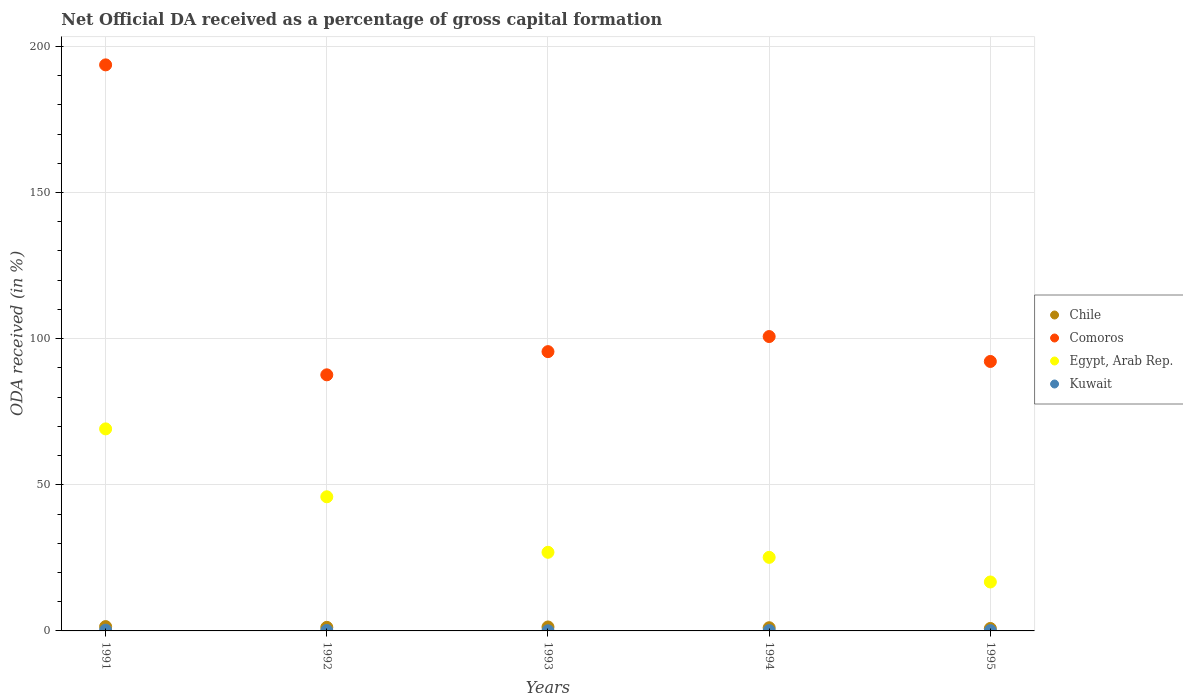Is the number of dotlines equal to the number of legend labels?
Provide a succinct answer. Yes. What is the net ODA received in Chile in 1993?
Your answer should be very brief. 1.35. Across all years, what is the maximum net ODA received in Chile?
Provide a succinct answer. 1.48. Across all years, what is the minimum net ODA received in Chile?
Provide a succinct answer. 0.84. In which year was the net ODA received in Comoros minimum?
Ensure brevity in your answer.  1992. What is the total net ODA received in Kuwait in the graph?
Offer a terse response. 0.67. What is the difference between the net ODA received in Kuwait in 1991 and that in 1995?
Offer a terse response. 0.15. What is the difference between the net ODA received in Egypt, Arab Rep. in 1991 and the net ODA received in Kuwait in 1995?
Provide a succinct answer. 69.03. What is the average net ODA received in Egypt, Arab Rep. per year?
Your answer should be very brief. 36.77. In the year 1992, what is the difference between the net ODA received in Chile and net ODA received in Comoros?
Make the answer very short. -86.4. In how many years, is the net ODA received in Kuwait greater than 110 %?
Offer a terse response. 0. What is the ratio of the net ODA received in Chile in 1993 to that in 1995?
Offer a terse response. 1.61. What is the difference between the highest and the second highest net ODA received in Kuwait?
Make the answer very short. 0.11. What is the difference between the highest and the lowest net ODA received in Chile?
Offer a terse response. 0.64. Is the sum of the net ODA received in Kuwait in 1992 and 1995 greater than the maximum net ODA received in Egypt, Arab Rep. across all years?
Ensure brevity in your answer.  No. Is it the case that in every year, the sum of the net ODA received in Comoros and net ODA received in Egypt, Arab Rep.  is greater than the sum of net ODA received in Kuwait and net ODA received in Chile?
Provide a short and direct response. No. Is it the case that in every year, the sum of the net ODA received in Chile and net ODA received in Kuwait  is greater than the net ODA received in Egypt, Arab Rep.?
Your response must be concise. No. Is the net ODA received in Kuwait strictly greater than the net ODA received in Chile over the years?
Offer a terse response. No. Is the net ODA received in Comoros strictly less than the net ODA received in Egypt, Arab Rep. over the years?
Your response must be concise. No. How many years are there in the graph?
Ensure brevity in your answer.  5. What is the difference between two consecutive major ticks on the Y-axis?
Give a very brief answer. 50. Are the values on the major ticks of Y-axis written in scientific E-notation?
Your answer should be compact. No. Does the graph contain grids?
Your response must be concise. Yes. Where does the legend appear in the graph?
Your response must be concise. Center right. How many legend labels are there?
Offer a terse response. 4. How are the legend labels stacked?
Provide a short and direct response. Vertical. What is the title of the graph?
Give a very brief answer. Net Official DA received as a percentage of gross capital formation. Does "New Caledonia" appear as one of the legend labels in the graph?
Give a very brief answer. No. What is the label or title of the X-axis?
Give a very brief answer. Years. What is the label or title of the Y-axis?
Offer a terse response. ODA received (in %). What is the ODA received (in %) of Chile in 1991?
Provide a short and direct response. 1.48. What is the ODA received (in %) of Comoros in 1991?
Provide a succinct answer. 193.68. What is the ODA received (in %) of Egypt, Arab Rep. in 1991?
Your response must be concise. 69.13. What is the ODA received (in %) of Kuwait in 1991?
Your response must be concise. 0.26. What is the ODA received (in %) in Chile in 1992?
Your response must be concise. 1.22. What is the ODA received (in %) in Comoros in 1992?
Give a very brief answer. 87.63. What is the ODA received (in %) in Egypt, Arab Rep. in 1992?
Offer a very short reply. 45.89. What is the ODA received (in %) of Kuwait in 1992?
Provide a succinct answer. 0.15. What is the ODA received (in %) of Chile in 1993?
Your response must be concise. 1.35. What is the ODA received (in %) in Comoros in 1993?
Offer a very short reply. 95.56. What is the ODA received (in %) of Egypt, Arab Rep. in 1993?
Give a very brief answer. 26.9. What is the ODA received (in %) in Kuwait in 1993?
Give a very brief answer. 0.05. What is the ODA received (in %) in Chile in 1994?
Your answer should be compact. 1.09. What is the ODA received (in %) in Comoros in 1994?
Provide a succinct answer. 100.72. What is the ODA received (in %) of Egypt, Arab Rep. in 1994?
Keep it short and to the point. 25.17. What is the ODA received (in %) of Kuwait in 1994?
Provide a short and direct response. 0.11. What is the ODA received (in %) of Chile in 1995?
Ensure brevity in your answer.  0.84. What is the ODA received (in %) of Comoros in 1995?
Provide a short and direct response. 92.2. What is the ODA received (in %) of Egypt, Arab Rep. in 1995?
Give a very brief answer. 16.75. What is the ODA received (in %) in Kuwait in 1995?
Your answer should be compact. 0.11. Across all years, what is the maximum ODA received (in %) of Chile?
Your answer should be very brief. 1.48. Across all years, what is the maximum ODA received (in %) in Comoros?
Make the answer very short. 193.68. Across all years, what is the maximum ODA received (in %) in Egypt, Arab Rep.?
Your answer should be very brief. 69.13. Across all years, what is the maximum ODA received (in %) of Kuwait?
Provide a succinct answer. 0.26. Across all years, what is the minimum ODA received (in %) in Chile?
Make the answer very short. 0.84. Across all years, what is the minimum ODA received (in %) of Comoros?
Your answer should be compact. 87.63. Across all years, what is the minimum ODA received (in %) in Egypt, Arab Rep.?
Keep it short and to the point. 16.75. Across all years, what is the minimum ODA received (in %) in Kuwait?
Your answer should be compact. 0.05. What is the total ODA received (in %) in Chile in the graph?
Your answer should be very brief. 5.99. What is the total ODA received (in %) in Comoros in the graph?
Offer a terse response. 569.79. What is the total ODA received (in %) in Egypt, Arab Rep. in the graph?
Your answer should be very brief. 183.85. What is the total ODA received (in %) in Kuwait in the graph?
Provide a succinct answer. 0.67. What is the difference between the ODA received (in %) of Chile in 1991 and that in 1992?
Give a very brief answer. 0.26. What is the difference between the ODA received (in %) of Comoros in 1991 and that in 1992?
Provide a succinct answer. 106.05. What is the difference between the ODA received (in %) of Egypt, Arab Rep. in 1991 and that in 1992?
Offer a terse response. 23.24. What is the difference between the ODA received (in %) of Kuwait in 1991 and that in 1992?
Provide a succinct answer. 0.11. What is the difference between the ODA received (in %) in Chile in 1991 and that in 1993?
Keep it short and to the point. 0.13. What is the difference between the ODA received (in %) of Comoros in 1991 and that in 1993?
Make the answer very short. 98.12. What is the difference between the ODA received (in %) of Egypt, Arab Rep. in 1991 and that in 1993?
Your answer should be compact. 42.23. What is the difference between the ODA received (in %) in Kuwait in 1991 and that in 1993?
Provide a short and direct response. 0.21. What is the difference between the ODA received (in %) in Chile in 1991 and that in 1994?
Provide a succinct answer. 0.39. What is the difference between the ODA received (in %) of Comoros in 1991 and that in 1994?
Make the answer very short. 92.96. What is the difference between the ODA received (in %) of Egypt, Arab Rep. in 1991 and that in 1994?
Make the answer very short. 43.96. What is the difference between the ODA received (in %) of Kuwait in 1991 and that in 1994?
Provide a short and direct response. 0.14. What is the difference between the ODA received (in %) of Chile in 1991 and that in 1995?
Offer a very short reply. 0.64. What is the difference between the ODA received (in %) of Comoros in 1991 and that in 1995?
Keep it short and to the point. 101.48. What is the difference between the ODA received (in %) of Egypt, Arab Rep. in 1991 and that in 1995?
Ensure brevity in your answer.  52.38. What is the difference between the ODA received (in %) in Kuwait in 1991 and that in 1995?
Your answer should be very brief. 0.15. What is the difference between the ODA received (in %) in Chile in 1992 and that in 1993?
Offer a terse response. -0.13. What is the difference between the ODA received (in %) in Comoros in 1992 and that in 1993?
Your answer should be very brief. -7.93. What is the difference between the ODA received (in %) in Egypt, Arab Rep. in 1992 and that in 1993?
Provide a short and direct response. 18.99. What is the difference between the ODA received (in %) in Kuwait in 1992 and that in 1993?
Provide a short and direct response. 0.1. What is the difference between the ODA received (in %) of Chile in 1992 and that in 1994?
Your response must be concise. 0.13. What is the difference between the ODA received (in %) of Comoros in 1992 and that in 1994?
Give a very brief answer. -13.1. What is the difference between the ODA received (in %) in Egypt, Arab Rep. in 1992 and that in 1994?
Provide a succinct answer. 20.72. What is the difference between the ODA received (in %) of Kuwait in 1992 and that in 1994?
Ensure brevity in your answer.  0.04. What is the difference between the ODA received (in %) in Chile in 1992 and that in 1995?
Offer a terse response. 0.39. What is the difference between the ODA received (in %) in Comoros in 1992 and that in 1995?
Your answer should be very brief. -4.57. What is the difference between the ODA received (in %) of Egypt, Arab Rep. in 1992 and that in 1995?
Offer a terse response. 29.15. What is the difference between the ODA received (in %) in Kuwait in 1992 and that in 1995?
Provide a short and direct response. 0.04. What is the difference between the ODA received (in %) in Chile in 1993 and that in 1994?
Your response must be concise. 0.26. What is the difference between the ODA received (in %) in Comoros in 1993 and that in 1994?
Provide a succinct answer. -5.16. What is the difference between the ODA received (in %) in Egypt, Arab Rep. in 1993 and that in 1994?
Provide a short and direct response. 1.73. What is the difference between the ODA received (in %) in Kuwait in 1993 and that in 1994?
Give a very brief answer. -0.06. What is the difference between the ODA received (in %) in Chile in 1993 and that in 1995?
Give a very brief answer. 0.51. What is the difference between the ODA received (in %) of Comoros in 1993 and that in 1995?
Offer a very short reply. 3.36. What is the difference between the ODA received (in %) of Egypt, Arab Rep. in 1993 and that in 1995?
Provide a succinct answer. 10.16. What is the difference between the ODA received (in %) of Kuwait in 1993 and that in 1995?
Provide a succinct answer. -0.06. What is the difference between the ODA received (in %) of Chile in 1994 and that in 1995?
Give a very brief answer. 0.26. What is the difference between the ODA received (in %) of Comoros in 1994 and that in 1995?
Your response must be concise. 8.52. What is the difference between the ODA received (in %) of Egypt, Arab Rep. in 1994 and that in 1995?
Your answer should be very brief. 8.42. What is the difference between the ODA received (in %) in Kuwait in 1994 and that in 1995?
Your answer should be very brief. 0.01. What is the difference between the ODA received (in %) in Chile in 1991 and the ODA received (in %) in Comoros in 1992?
Offer a very short reply. -86.14. What is the difference between the ODA received (in %) of Chile in 1991 and the ODA received (in %) of Egypt, Arab Rep. in 1992?
Keep it short and to the point. -44.41. What is the difference between the ODA received (in %) of Chile in 1991 and the ODA received (in %) of Kuwait in 1992?
Make the answer very short. 1.34. What is the difference between the ODA received (in %) in Comoros in 1991 and the ODA received (in %) in Egypt, Arab Rep. in 1992?
Make the answer very short. 147.79. What is the difference between the ODA received (in %) of Comoros in 1991 and the ODA received (in %) of Kuwait in 1992?
Offer a very short reply. 193.53. What is the difference between the ODA received (in %) in Egypt, Arab Rep. in 1991 and the ODA received (in %) in Kuwait in 1992?
Provide a succinct answer. 68.98. What is the difference between the ODA received (in %) of Chile in 1991 and the ODA received (in %) of Comoros in 1993?
Provide a succinct answer. -94.08. What is the difference between the ODA received (in %) in Chile in 1991 and the ODA received (in %) in Egypt, Arab Rep. in 1993?
Provide a short and direct response. -25.42. What is the difference between the ODA received (in %) in Chile in 1991 and the ODA received (in %) in Kuwait in 1993?
Give a very brief answer. 1.43. What is the difference between the ODA received (in %) in Comoros in 1991 and the ODA received (in %) in Egypt, Arab Rep. in 1993?
Offer a terse response. 166.78. What is the difference between the ODA received (in %) in Comoros in 1991 and the ODA received (in %) in Kuwait in 1993?
Give a very brief answer. 193.63. What is the difference between the ODA received (in %) of Egypt, Arab Rep. in 1991 and the ODA received (in %) of Kuwait in 1993?
Your answer should be compact. 69.08. What is the difference between the ODA received (in %) of Chile in 1991 and the ODA received (in %) of Comoros in 1994?
Your answer should be very brief. -99.24. What is the difference between the ODA received (in %) of Chile in 1991 and the ODA received (in %) of Egypt, Arab Rep. in 1994?
Your answer should be compact. -23.69. What is the difference between the ODA received (in %) in Chile in 1991 and the ODA received (in %) in Kuwait in 1994?
Keep it short and to the point. 1.37. What is the difference between the ODA received (in %) in Comoros in 1991 and the ODA received (in %) in Egypt, Arab Rep. in 1994?
Provide a succinct answer. 168.51. What is the difference between the ODA received (in %) in Comoros in 1991 and the ODA received (in %) in Kuwait in 1994?
Your response must be concise. 193.57. What is the difference between the ODA received (in %) of Egypt, Arab Rep. in 1991 and the ODA received (in %) of Kuwait in 1994?
Provide a succinct answer. 69.02. What is the difference between the ODA received (in %) in Chile in 1991 and the ODA received (in %) in Comoros in 1995?
Your response must be concise. -90.72. What is the difference between the ODA received (in %) of Chile in 1991 and the ODA received (in %) of Egypt, Arab Rep. in 1995?
Keep it short and to the point. -15.27. What is the difference between the ODA received (in %) of Chile in 1991 and the ODA received (in %) of Kuwait in 1995?
Offer a very short reply. 1.38. What is the difference between the ODA received (in %) of Comoros in 1991 and the ODA received (in %) of Egypt, Arab Rep. in 1995?
Ensure brevity in your answer.  176.93. What is the difference between the ODA received (in %) of Comoros in 1991 and the ODA received (in %) of Kuwait in 1995?
Provide a succinct answer. 193.57. What is the difference between the ODA received (in %) in Egypt, Arab Rep. in 1991 and the ODA received (in %) in Kuwait in 1995?
Offer a terse response. 69.03. What is the difference between the ODA received (in %) of Chile in 1992 and the ODA received (in %) of Comoros in 1993?
Provide a short and direct response. -94.34. What is the difference between the ODA received (in %) of Chile in 1992 and the ODA received (in %) of Egypt, Arab Rep. in 1993?
Keep it short and to the point. -25.68. What is the difference between the ODA received (in %) of Chile in 1992 and the ODA received (in %) of Kuwait in 1993?
Make the answer very short. 1.17. What is the difference between the ODA received (in %) in Comoros in 1992 and the ODA received (in %) in Egypt, Arab Rep. in 1993?
Make the answer very short. 60.72. What is the difference between the ODA received (in %) in Comoros in 1992 and the ODA received (in %) in Kuwait in 1993?
Provide a short and direct response. 87.58. What is the difference between the ODA received (in %) of Egypt, Arab Rep. in 1992 and the ODA received (in %) of Kuwait in 1993?
Give a very brief answer. 45.84. What is the difference between the ODA received (in %) of Chile in 1992 and the ODA received (in %) of Comoros in 1994?
Offer a terse response. -99.5. What is the difference between the ODA received (in %) in Chile in 1992 and the ODA received (in %) in Egypt, Arab Rep. in 1994?
Keep it short and to the point. -23.95. What is the difference between the ODA received (in %) of Chile in 1992 and the ODA received (in %) of Kuwait in 1994?
Make the answer very short. 1.11. What is the difference between the ODA received (in %) in Comoros in 1992 and the ODA received (in %) in Egypt, Arab Rep. in 1994?
Give a very brief answer. 62.45. What is the difference between the ODA received (in %) in Comoros in 1992 and the ODA received (in %) in Kuwait in 1994?
Give a very brief answer. 87.51. What is the difference between the ODA received (in %) in Egypt, Arab Rep. in 1992 and the ODA received (in %) in Kuwait in 1994?
Keep it short and to the point. 45.78. What is the difference between the ODA received (in %) in Chile in 1992 and the ODA received (in %) in Comoros in 1995?
Provide a succinct answer. -90.98. What is the difference between the ODA received (in %) of Chile in 1992 and the ODA received (in %) of Egypt, Arab Rep. in 1995?
Your response must be concise. -15.52. What is the difference between the ODA received (in %) in Chile in 1992 and the ODA received (in %) in Kuwait in 1995?
Offer a terse response. 1.12. What is the difference between the ODA received (in %) in Comoros in 1992 and the ODA received (in %) in Egypt, Arab Rep. in 1995?
Your answer should be compact. 70.88. What is the difference between the ODA received (in %) of Comoros in 1992 and the ODA received (in %) of Kuwait in 1995?
Give a very brief answer. 87.52. What is the difference between the ODA received (in %) in Egypt, Arab Rep. in 1992 and the ODA received (in %) in Kuwait in 1995?
Ensure brevity in your answer.  45.79. What is the difference between the ODA received (in %) in Chile in 1993 and the ODA received (in %) in Comoros in 1994?
Your answer should be compact. -99.37. What is the difference between the ODA received (in %) in Chile in 1993 and the ODA received (in %) in Egypt, Arab Rep. in 1994?
Give a very brief answer. -23.82. What is the difference between the ODA received (in %) in Chile in 1993 and the ODA received (in %) in Kuwait in 1994?
Ensure brevity in your answer.  1.24. What is the difference between the ODA received (in %) of Comoros in 1993 and the ODA received (in %) of Egypt, Arab Rep. in 1994?
Provide a short and direct response. 70.39. What is the difference between the ODA received (in %) in Comoros in 1993 and the ODA received (in %) in Kuwait in 1994?
Keep it short and to the point. 95.45. What is the difference between the ODA received (in %) in Egypt, Arab Rep. in 1993 and the ODA received (in %) in Kuwait in 1994?
Provide a short and direct response. 26.79. What is the difference between the ODA received (in %) in Chile in 1993 and the ODA received (in %) in Comoros in 1995?
Your answer should be compact. -90.85. What is the difference between the ODA received (in %) in Chile in 1993 and the ODA received (in %) in Egypt, Arab Rep. in 1995?
Provide a short and direct response. -15.4. What is the difference between the ODA received (in %) in Chile in 1993 and the ODA received (in %) in Kuwait in 1995?
Provide a succinct answer. 1.25. What is the difference between the ODA received (in %) in Comoros in 1993 and the ODA received (in %) in Egypt, Arab Rep. in 1995?
Your answer should be compact. 78.81. What is the difference between the ODA received (in %) of Comoros in 1993 and the ODA received (in %) of Kuwait in 1995?
Provide a succinct answer. 95.45. What is the difference between the ODA received (in %) of Egypt, Arab Rep. in 1993 and the ODA received (in %) of Kuwait in 1995?
Your answer should be compact. 26.8. What is the difference between the ODA received (in %) in Chile in 1994 and the ODA received (in %) in Comoros in 1995?
Offer a terse response. -91.1. What is the difference between the ODA received (in %) of Chile in 1994 and the ODA received (in %) of Egypt, Arab Rep. in 1995?
Make the answer very short. -15.65. What is the difference between the ODA received (in %) of Comoros in 1994 and the ODA received (in %) of Egypt, Arab Rep. in 1995?
Your answer should be compact. 83.97. What is the difference between the ODA received (in %) of Comoros in 1994 and the ODA received (in %) of Kuwait in 1995?
Give a very brief answer. 100.62. What is the difference between the ODA received (in %) of Egypt, Arab Rep. in 1994 and the ODA received (in %) of Kuwait in 1995?
Your response must be concise. 25.07. What is the average ODA received (in %) in Chile per year?
Give a very brief answer. 1.2. What is the average ODA received (in %) of Comoros per year?
Provide a succinct answer. 113.96. What is the average ODA received (in %) of Egypt, Arab Rep. per year?
Keep it short and to the point. 36.77. What is the average ODA received (in %) of Kuwait per year?
Ensure brevity in your answer.  0.13. In the year 1991, what is the difference between the ODA received (in %) of Chile and ODA received (in %) of Comoros?
Offer a terse response. -192.2. In the year 1991, what is the difference between the ODA received (in %) in Chile and ODA received (in %) in Egypt, Arab Rep.?
Your answer should be compact. -67.65. In the year 1991, what is the difference between the ODA received (in %) in Chile and ODA received (in %) in Kuwait?
Keep it short and to the point. 1.23. In the year 1991, what is the difference between the ODA received (in %) of Comoros and ODA received (in %) of Egypt, Arab Rep.?
Offer a terse response. 124.55. In the year 1991, what is the difference between the ODA received (in %) in Comoros and ODA received (in %) in Kuwait?
Offer a very short reply. 193.42. In the year 1991, what is the difference between the ODA received (in %) in Egypt, Arab Rep. and ODA received (in %) in Kuwait?
Keep it short and to the point. 68.88. In the year 1992, what is the difference between the ODA received (in %) in Chile and ODA received (in %) in Comoros?
Offer a terse response. -86.4. In the year 1992, what is the difference between the ODA received (in %) of Chile and ODA received (in %) of Egypt, Arab Rep.?
Provide a short and direct response. -44.67. In the year 1992, what is the difference between the ODA received (in %) in Chile and ODA received (in %) in Kuwait?
Your answer should be very brief. 1.08. In the year 1992, what is the difference between the ODA received (in %) of Comoros and ODA received (in %) of Egypt, Arab Rep.?
Make the answer very short. 41.73. In the year 1992, what is the difference between the ODA received (in %) of Comoros and ODA received (in %) of Kuwait?
Offer a very short reply. 87.48. In the year 1992, what is the difference between the ODA received (in %) in Egypt, Arab Rep. and ODA received (in %) in Kuwait?
Ensure brevity in your answer.  45.75. In the year 1993, what is the difference between the ODA received (in %) of Chile and ODA received (in %) of Comoros?
Offer a terse response. -94.21. In the year 1993, what is the difference between the ODA received (in %) in Chile and ODA received (in %) in Egypt, Arab Rep.?
Offer a very short reply. -25.55. In the year 1993, what is the difference between the ODA received (in %) of Chile and ODA received (in %) of Kuwait?
Provide a short and direct response. 1.3. In the year 1993, what is the difference between the ODA received (in %) in Comoros and ODA received (in %) in Egypt, Arab Rep.?
Provide a succinct answer. 68.66. In the year 1993, what is the difference between the ODA received (in %) in Comoros and ODA received (in %) in Kuwait?
Offer a terse response. 95.51. In the year 1993, what is the difference between the ODA received (in %) of Egypt, Arab Rep. and ODA received (in %) of Kuwait?
Your answer should be compact. 26.85. In the year 1994, what is the difference between the ODA received (in %) in Chile and ODA received (in %) in Comoros?
Provide a succinct answer. -99.63. In the year 1994, what is the difference between the ODA received (in %) in Chile and ODA received (in %) in Egypt, Arab Rep.?
Provide a succinct answer. -24.08. In the year 1994, what is the difference between the ODA received (in %) in Chile and ODA received (in %) in Kuwait?
Your answer should be compact. 0.98. In the year 1994, what is the difference between the ODA received (in %) in Comoros and ODA received (in %) in Egypt, Arab Rep.?
Provide a short and direct response. 75.55. In the year 1994, what is the difference between the ODA received (in %) of Comoros and ODA received (in %) of Kuwait?
Provide a short and direct response. 100.61. In the year 1994, what is the difference between the ODA received (in %) of Egypt, Arab Rep. and ODA received (in %) of Kuwait?
Provide a succinct answer. 25.06. In the year 1995, what is the difference between the ODA received (in %) in Chile and ODA received (in %) in Comoros?
Your response must be concise. -91.36. In the year 1995, what is the difference between the ODA received (in %) in Chile and ODA received (in %) in Egypt, Arab Rep.?
Give a very brief answer. -15.91. In the year 1995, what is the difference between the ODA received (in %) in Chile and ODA received (in %) in Kuwait?
Provide a succinct answer. 0.73. In the year 1995, what is the difference between the ODA received (in %) in Comoros and ODA received (in %) in Egypt, Arab Rep.?
Make the answer very short. 75.45. In the year 1995, what is the difference between the ODA received (in %) in Comoros and ODA received (in %) in Kuwait?
Your response must be concise. 92.09. In the year 1995, what is the difference between the ODA received (in %) of Egypt, Arab Rep. and ODA received (in %) of Kuwait?
Offer a very short reply. 16.64. What is the ratio of the ODA received (in %) of Chile in 1991 to that in 1992?
Ensure brevity in your answer.  1.21. What is the ratio of the ODA received (in %) of Comoros in 1991 to that in 1992?
Ensure brevity in your answer.  2.21. What is the ratio of the ODA received (in %) of Egypt, Arab Rep. in 1991 to that in 1992?
Your answer should be compact. 1.51. What is the ratio of the ODA received (in %) of Kuwait in 1991 to that in 1992?
Make the answer very short. 1.74. What is the ratio of the ODA received (in %) of Chile in 1991 to that in 1993?
Provide a short and direct response. 1.1. What is the ratio of the ODA received (in %) in Comoros in 1991 to that in 1993?
Your answer should be compact. 2.03. What is the ratio of the ODA received (in %) in Egypt, Arab Rep. in 1991 to that in 1993?
Ensure brevity in your answer.  2.57. What is the ratio of the ODA received (in %) in Kuwait in 1991 to that in 1993?
Your answer should be compact. 5.17. What is the ratio of the ODA received (in %) in Chile in 1991 to that in 1994?
Offer a terse response. 1.35. What is the ratio of the ODA received (in %) of Comoros in 1991 to that in 1994?
Ensure brevity in your answer.  1.92. What is the ratio of the ODA received (in %) of Egypt, Arab Rep. in 1991 to that in 1994?
Make the answer very short. 2.75. What is the ratio of the ODA received (in %) in Kuwait in 1991 to that in 1994?
Give a very brief answer. 2.29. What is the ratio of the ODA received (in %) of Chile in 1991 to that in 1995?
Provide a short and direct response. 1.77. What is the ratio of the ODA received (in %) in Comoros in 1991 to that in 1995?
Keep it short and to the point. 2.1. What is the ratio of the ODA received (in %) in Egypt, Arab Rep. in 1991 to that in 1995?
Offer a very short reply. 4.13. What is the ratio of the ODA received (in %) in Kuwait in 1991 to that in 1995?
Provide a short and direct response. 2.42. What is the ratio of the ODA received (in %) of Chile in 1992 to that in 1993?
Provide a succinct answer. 0.91. What is the ratio of the ODA received (in %) of Comoros in 1992 to that in 1993?
Give a very brief answer. 0.92. What is the ratio of the ODA received (in %) of Egypt, Arab Rep. in 1992 to that in 1993?
Give a very brief answer. 1.71. What is the ratio of the ODA received (in %) of Kuwait in 1992 to that in 1993?
Keep it short and to the point. 2.98. What is the ratio of the ODA received (in %) of Chile in 1992 to that in 1994?
Your answer should be very brief. 1.12. What is the ratio of the ODA received (in %) in Comoros in 1992 to that in 1994?
Offer a terse response. 0.87. What is the ratio of the ODA received (in %) in Egypt, Arab Rep. in 1992 to that in 1994?
Keep it short and to the point. 1.82. What is the ratio of the ODA received (in %) in Kuwait in 1992 to that in 1994?
Provide a short and direct response. 1.32. What is the ratio of the ODA received (in %) of Chile in 1992 to that in 1995?
Your answer should be very brief. 1.46. What is the ratio of the ODA received (in %) in Comoros in 1992 to that in 1995?
Your response must be concise. 0.95. What is the ratio of the ODA received (in %) in Egypt, Arab Rep. in 1992 to that in 1995?
Offer a very short reply. 2.74. What is the ratio of the ODA received (in %) in Kuwait in 1992 to that in 1995?
Provide a succinct answer. 1.39. What is the ratio of the ODA received (in %) of Chile in 1993 to that in 1994?
Provide a short and direct response. 1.23. What is the ratio of the ODA received (in %) in Comoros in 1993 to that in 1994?
Keep it short and to the point. 0.95. What is the ratio of the ODA received (in %) in Egypt, Arab Rep. in 1993 to that in 1994?
Ensure brevity in your answer.  1.07. What is the ratio of the ODA received (in %) in Kuwait in 1993 to that in 1994?
Make the answer very short. 0.44. What is the ratio of the ODA received (in %) in Chile in 1993 to that in 1995?
Your answer should be very brief. 1.61. What is the ratio of the ODA received (in %) in Comoros in 1993 to that in 1995?
Provide a short and direct response. 1.04. What is the ratio of the ODA received (in %) in Egypt, Arab Rep. in 1993 to that in 1995?
Your answer should be very brief. 1.61. What is the ratio of the ODA received (in %) in Kuwait in 1993 to that in 1995?
Your answer should be compact. 0.47. What is the ratio of the ODA received (in %) of Chile in 1994 to that in 1995?
Offer a very short reply. 1.31. What is the ratio of the ODA received (in %) of Comoros in 1994 to that in 1995?
Your answer should be very brief. 1.09. What is the ratio of the ODA received (in %) in Egypt, Arab Rep. in 1994 to that in 1995?
Your response must be concise. 1.5. What is the ratio of the ODA received (in %) of Kuwait in 1994 to that in 1995?
Offer a very short reply. 1.06. What is the difference between the highest and the second highest ODA received (in %) of Chile?
Make the answer very short. 0.13. What is the difference between the highest and the second highest ODA received (in %) in Comoros?
Give a very brief answer. 92.96. What is the difference between the highest and the second highest ODA received (in %) in Egypt, Arab Rep.?
Give a very brief answer. 23.24. What is the difference between the highest and the second highest ODA received (in %) in Kuwait?
Ensure brevity in your answer.  0.11. What is the difference between the highest and the lowest ODA received (in %) in Chile?
Ensure brevity in your answer.  0.64. What is the difference between the highest and the lowest ODA received (in %) of Comoros?
Your response must be concise. 106.05. What is the difference between the highest and the lowest ODA received (in %) of Egypt, Arab Rep.?
Offer a terse response. 52.38. What is the difference between the highest and the lowest ODA received (in %) of Kuwait?
Offer a terse response. 0.21. 